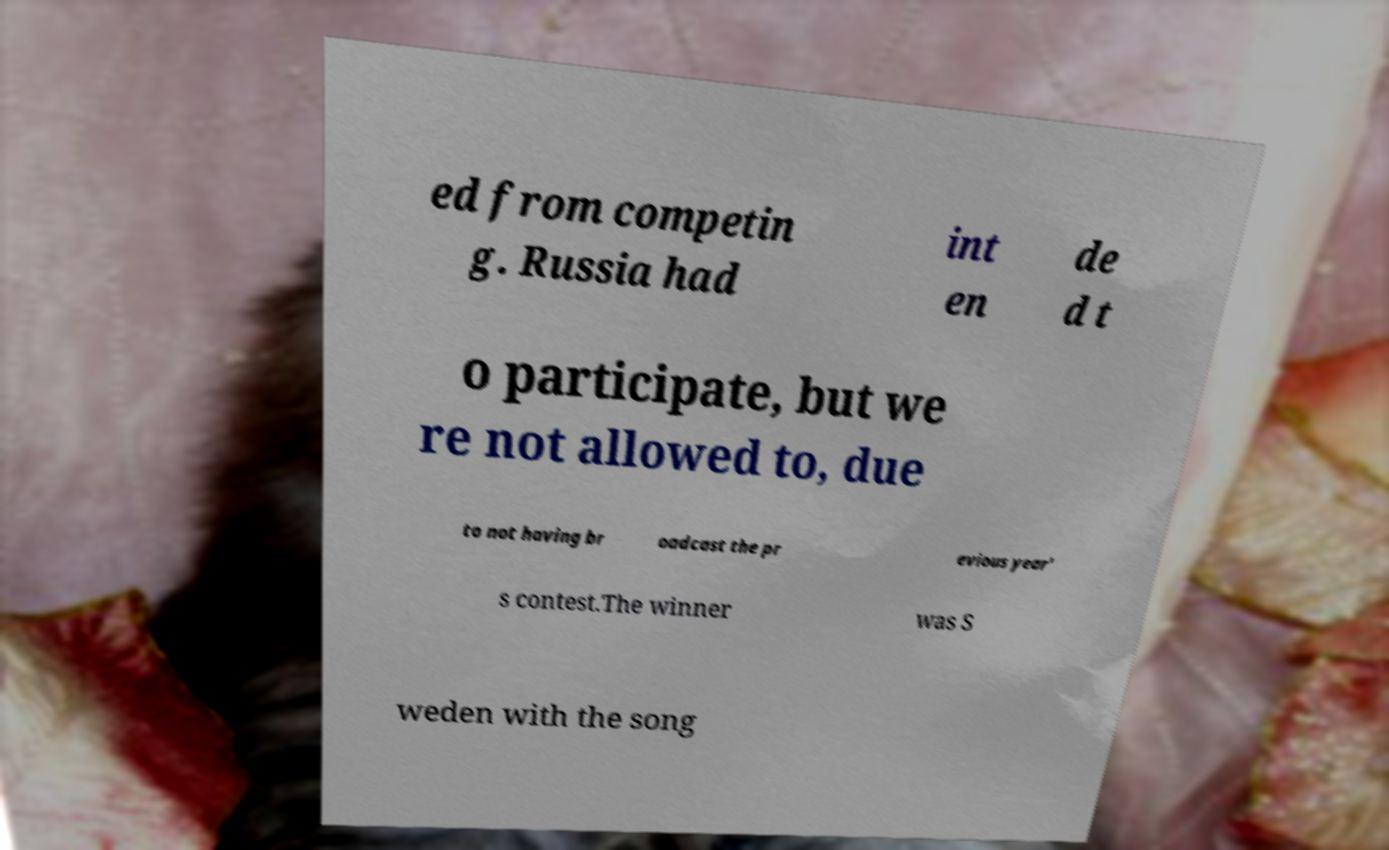I need the written content from this picture converted into text. Can you do that? ed from competin g. Russia had int en de d t o participate, but we re not allowed to, due to not having br oadcast the pr evious year' s contest.The winner was S weden with the song 